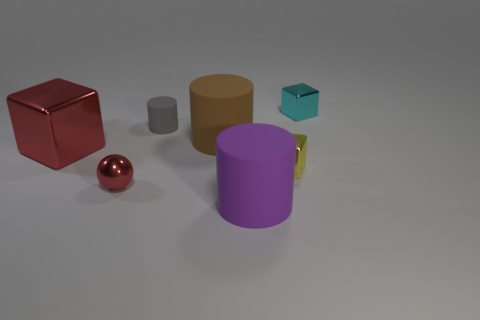What number of other objects are the same color as the metal sphere?
Make the answer very short. 1. What number of shiny things have the same color as the shiny sphere?
Make the answer very short. 1. Are there the same number of gray cylinders that are behind the small gray rubber cylinder and large shiny blocks in front of the tiny red sphere?
Provide a succinct answer. Yes. There is a red object that is in front of the big metallic block; does it have the same size as the cube that is behind the gray object?
Ensure brevity in your answer.  Yes. What shape is the red object left of the small thing in front of the tiny metal block to the left of the cyan thing?
Give a very brief answer. Cube. Are there any other things that are the same material as the small yellow thing?
Your answer should be compact. Yes. There is a cyan thing that is the same shape as the big red object; what size is it?
Your response must be concise. Small. The small object that is on the right side of the purple object and in front of the large brown object is what color?
Give a very brief answer. Yellow. Are the tiny yellow object and the block to the right of the yellow thing made of the same material?
Your answer should be very brief. Yes. Is the number of metallic spheres to the right of the big brown cylinder less than the number of green spheres?
Make the answer very short. No. 